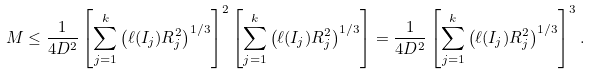<formula> <loc_0><loc_0><loc_500><loc_500>M \leq \frac { 1 } { 4 D ^ { 2 } } \left [ \sum _ { j = 1 } ^ { k } \left ( \ell ( I _ { j } ) R _ { j } ^ { 2 } \right ) ^ { 1 / 3 } \right ] ^ { 2 } \left [ \sum _ { j = 1 } ^ { k } \left ( \ell ( I _ { j } ) R _ { j } ^ { 2 } \right ) ^ { 1 / 3 } \right ] = \frac { 1 } { 4 D ^ { 2 } } \left [ \sum _ { j = 1 } ^ { k } \left ( \ell ( I _ { j } ) R _ { j } ^ { 2 } \right ) ^ { 1 / 3 } \right ] ^ { 3 } .</formula> 